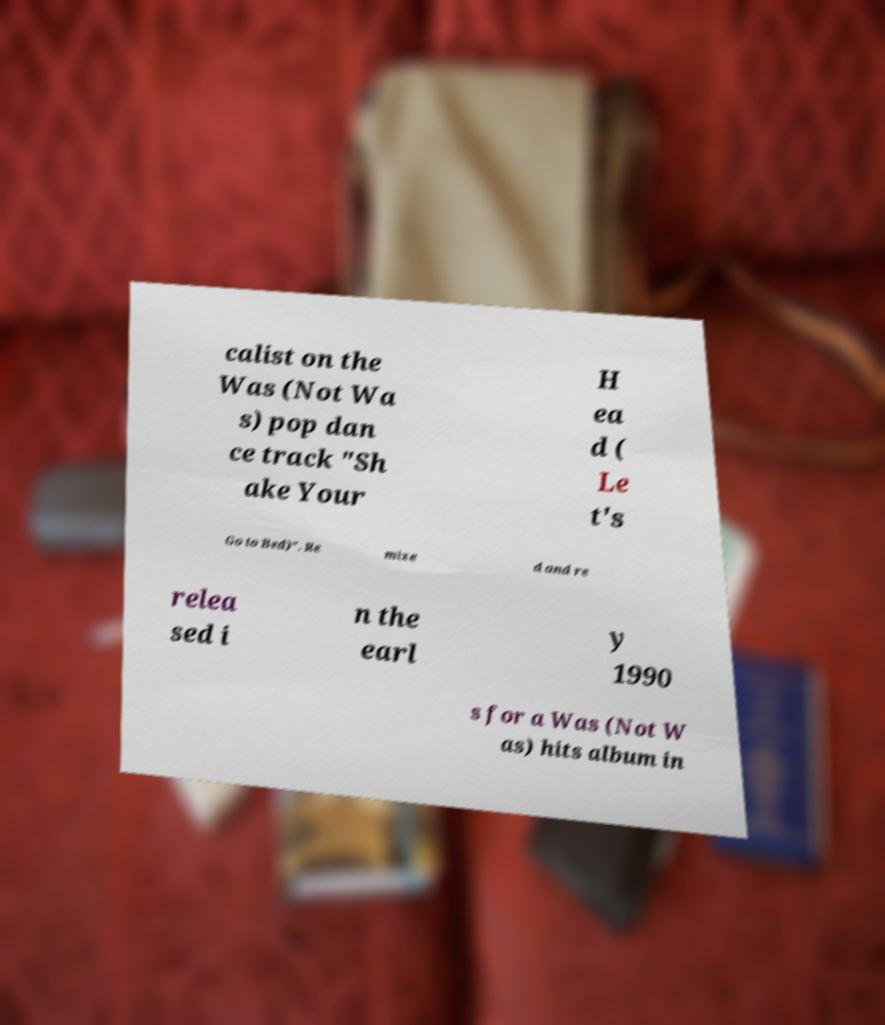Please identify and transcribe the text found in this image. calist on the Was (Not Wa s) pop dan ce track "Sh ake Your H ea d ( Le t's Go to Bed)". Re mixe d and re relea sed i n the earl y 1990 s for a Was (Not W as) hits album in 